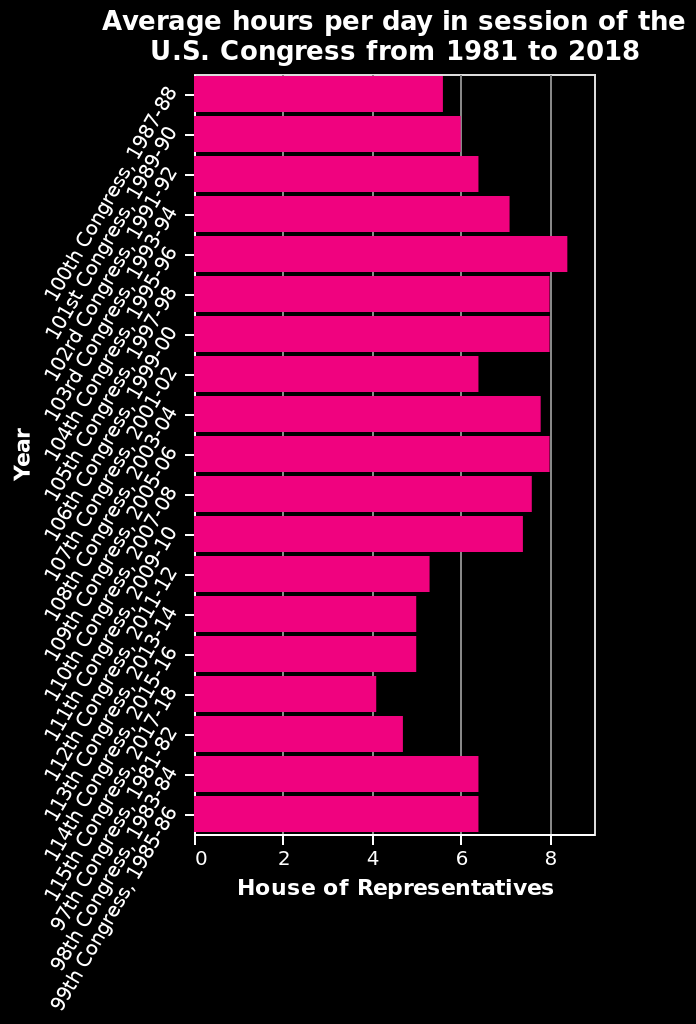<image>
Have Congress sessions become shorter over time? Yes, on average Congress sessions have gotten shorter, with 2011-2018 having less than 5 hours on average. 